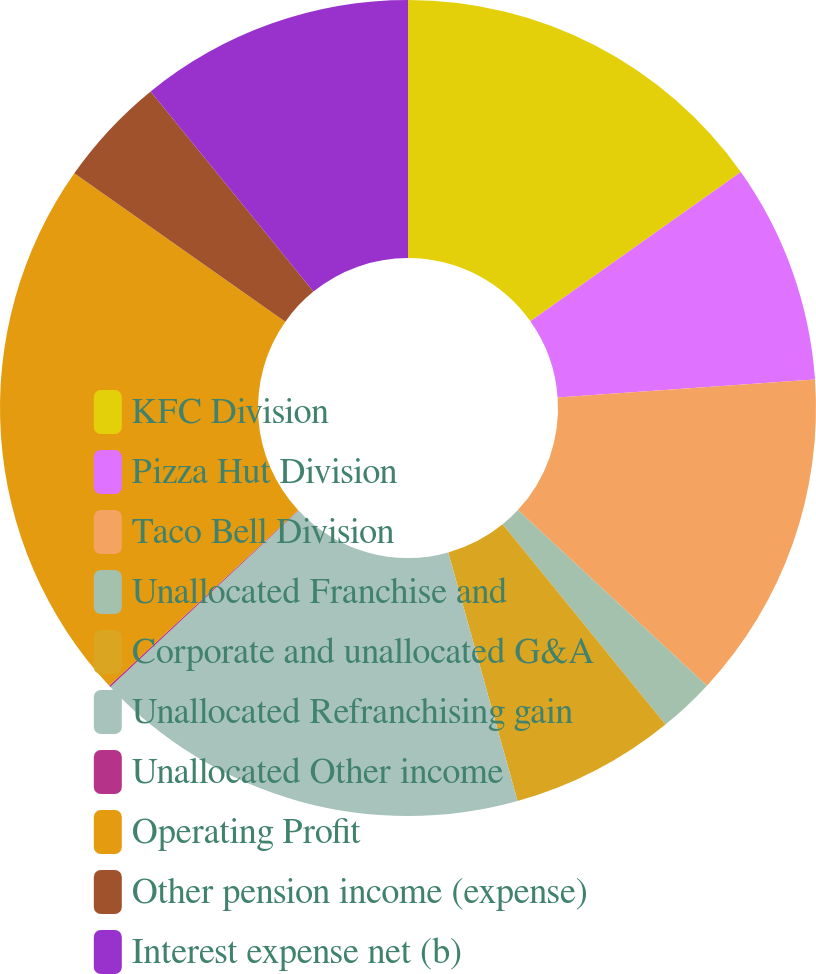Convert chart to OTSL. <chart><loc_0><loc_0><loc_500><loc_500><pie_chart><fcel>KFC Division<fcel>Pizza Hut Division<fcel>Taco Bell Division<fcel>Unallocated Franchise and<fcel>Corporate and unallocated G&A<fcel>Unallocated Refranchising gain<fcel>Unallocated Other income<fcel>Operating Profit<fcel>Other pension income (expense)<fcel>Interest expense net (b)<nl><fcel>15.18%<fcel>8.7%<fcel>13.02%<fcel>2.22%<fcel>6.54%<fcel>17.34%<fcel>0.06%<fcel>21.67%<fcel>4.38%<fcel>10.86%<nl></chart> 